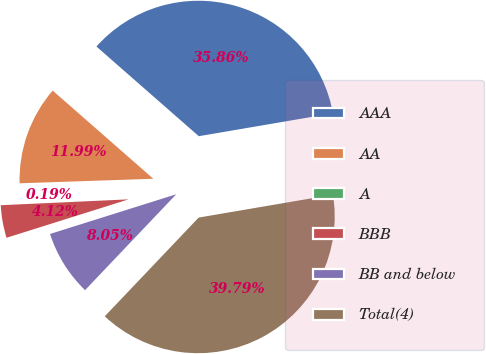<chart> <loc_0><loc_0><loc_500><loc_500><pie_chart><fcel>AAA<fcel>AA<fcel>A<fcel>BBB<fcel>BB and below<fcel>Total(4)<nl><fcel>35.86%<fcel>11.99%<fcel>0.19%<fcel>4.12%<fcel>8.05%<fcel>39.79%<nl></chart> 